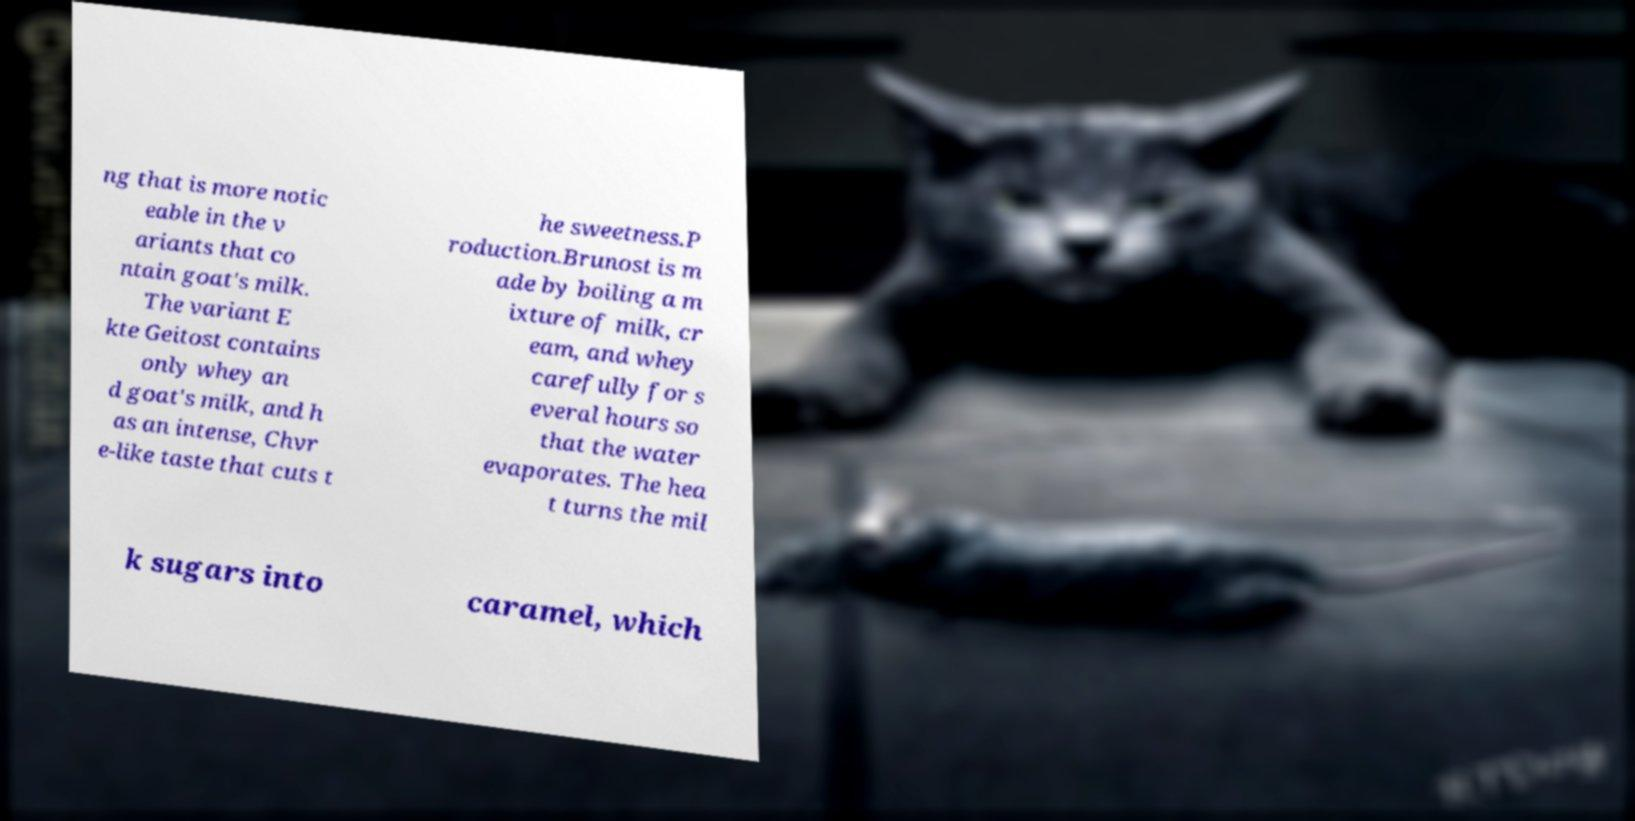Please read and relay the text visible in this image. What does it say? ng that is more notic eable in the v ariants that co ntain goat's milk. The variant E kte Geitost contains only whey an d goat's milk, and h as an intense, Chvr e-like taste that cuts t he sweetness.P roduction.Brunost is m ade by boiling a m ixture of milk, cr eam, and whey carefully for s everal hours so that the water evaporates. The hea t turns the mil k sugars into caramel, which 